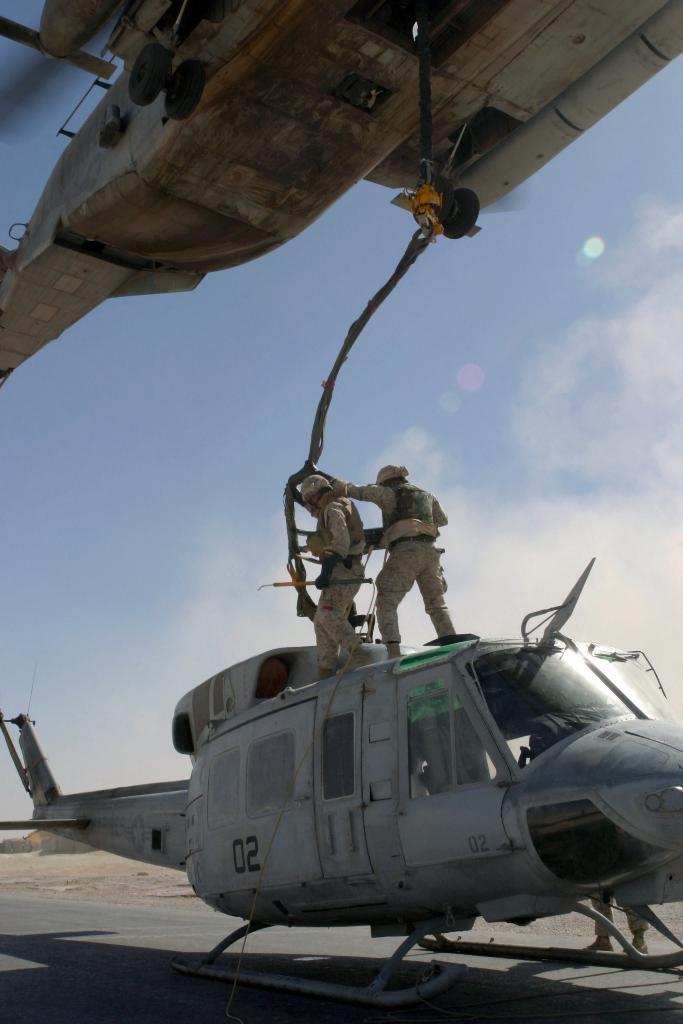<image>
Relay a brief, clear account of the picture shown. A helicopter with the number 02 written on the side 